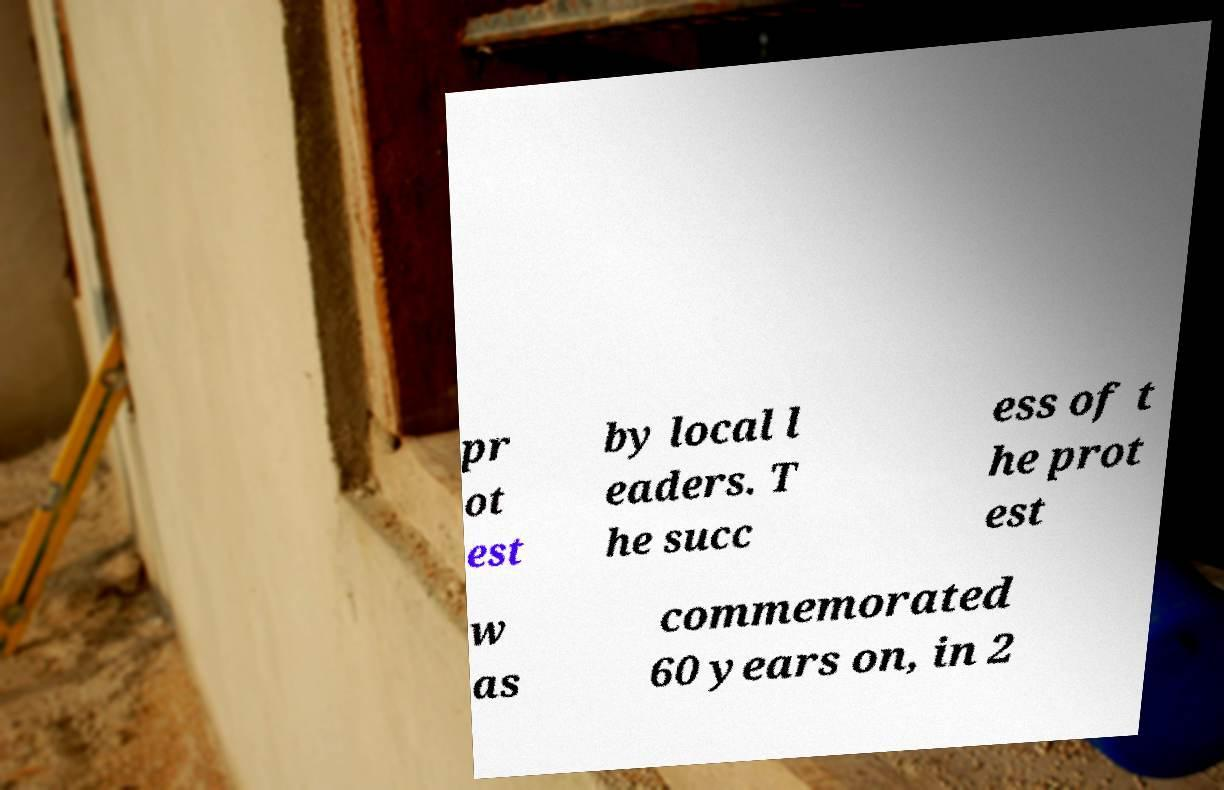Can you accurately transcribe the text from the provided image for me? pr ot est by local l eaders. T he succ ess of t he prot est w as commemorated 60 years on, in 2 